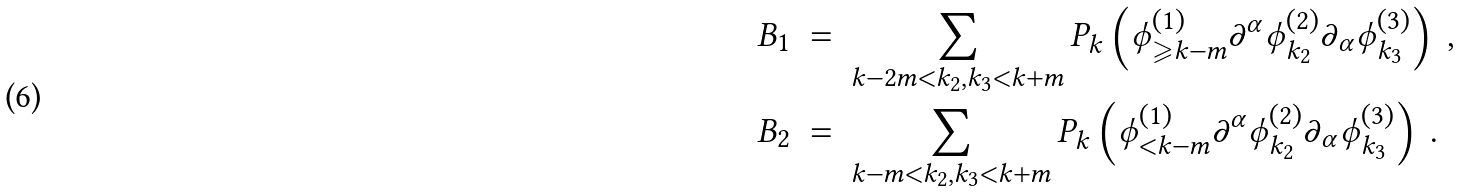<formula> <loc_0><loc_0><loc_500><loc_500>B _ { 1 } \ & = \ \sum _ { k - 2 m < k _ { 2 } , k _ { 3 } < k + m } P _ { k } \left ( \phi ^ { ( 1 ) } _ { \geqslant k - m } \partial ^ { \alpha } \phi ^ { ( 2 ) } _ { k _ { 2 } } \partial _ { \alpha } \phi ^ { ( 3 ) } _ { k _ { 3 } } \right ) \ , \\ B _ { 2 } \ & = \ \sum _ { k - m < k _ { 2 } , k _ { 3 } < k + m } P _ { k } \left ( \phi ^ { ( 1 ) } _ { < k - m } \partial ^ { \alpha } \phi ^ { ( 2 ) } _ { k _ { 2 } } \partial _ { \alpha } \phi ^ { ( 3 ) } _ { k _ { 3 } } \right ) \ .</formula> 